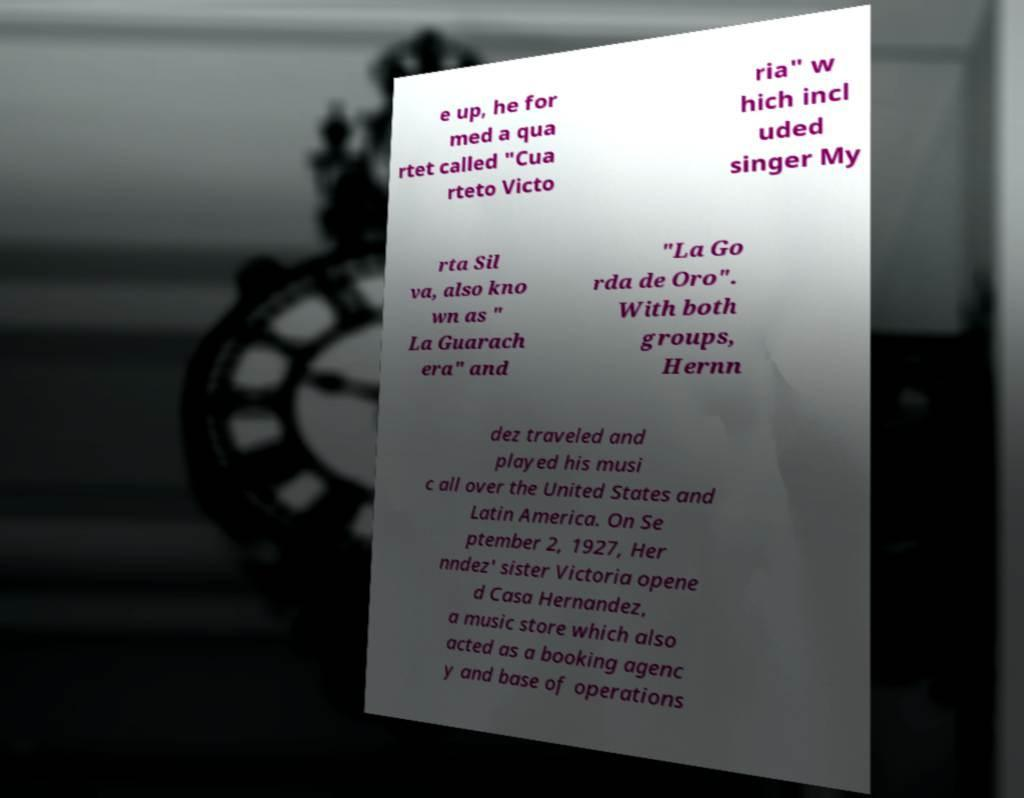I need the written content from this picture converted into text. Can you do that? e up, he for med a qua rtet called "Cua rteto Victo ria" w hich incl uded singer My rta Sil va, also kno wn as " La Guarach era" and "La Go rda de Oro". With both groups, Hernn dez traveled and played his musi c all over the United States and Latin America. On Se ptember 2, 1927, Her nndez' sister Victoria opene d Casa Hernandez, a music store which also acted as a booking agenc y and base of operations 